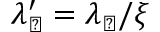Convert formula to latex. <formula><loc_0><loc_0><loc_500><loc_500>\lambda _ { \perp } ^ { \prime } = \lambda _ { \perp } / \xi</formula> 